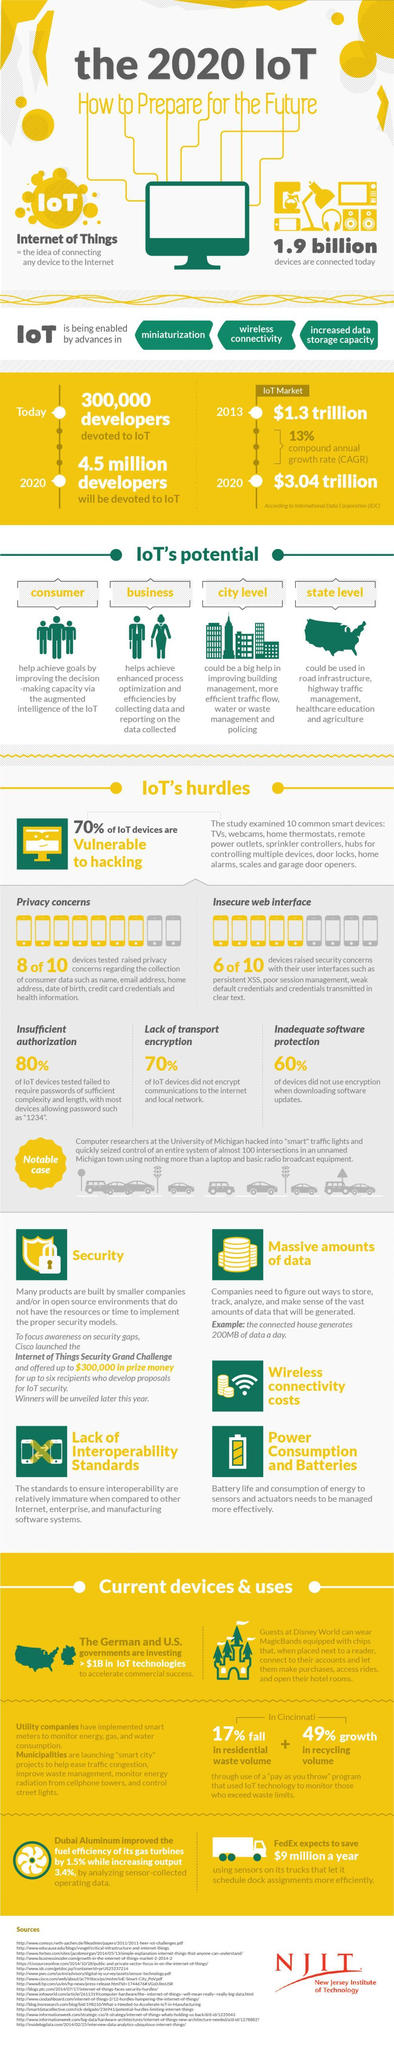What percent of the IoT devices do not encrypt communications to the internet & local netwrok?
Answer the question with a short phrase. 70% What percent of the IoT devices did not use encryption when downloading software updates? 60% What is the IoT market value in 2020 according to the IDC? $3.04 trillion What percentage of IoT devices are not vulnerable to hacking? 30% What is the IoT market value in 2013 according to the IDC? $1.3 trillion 